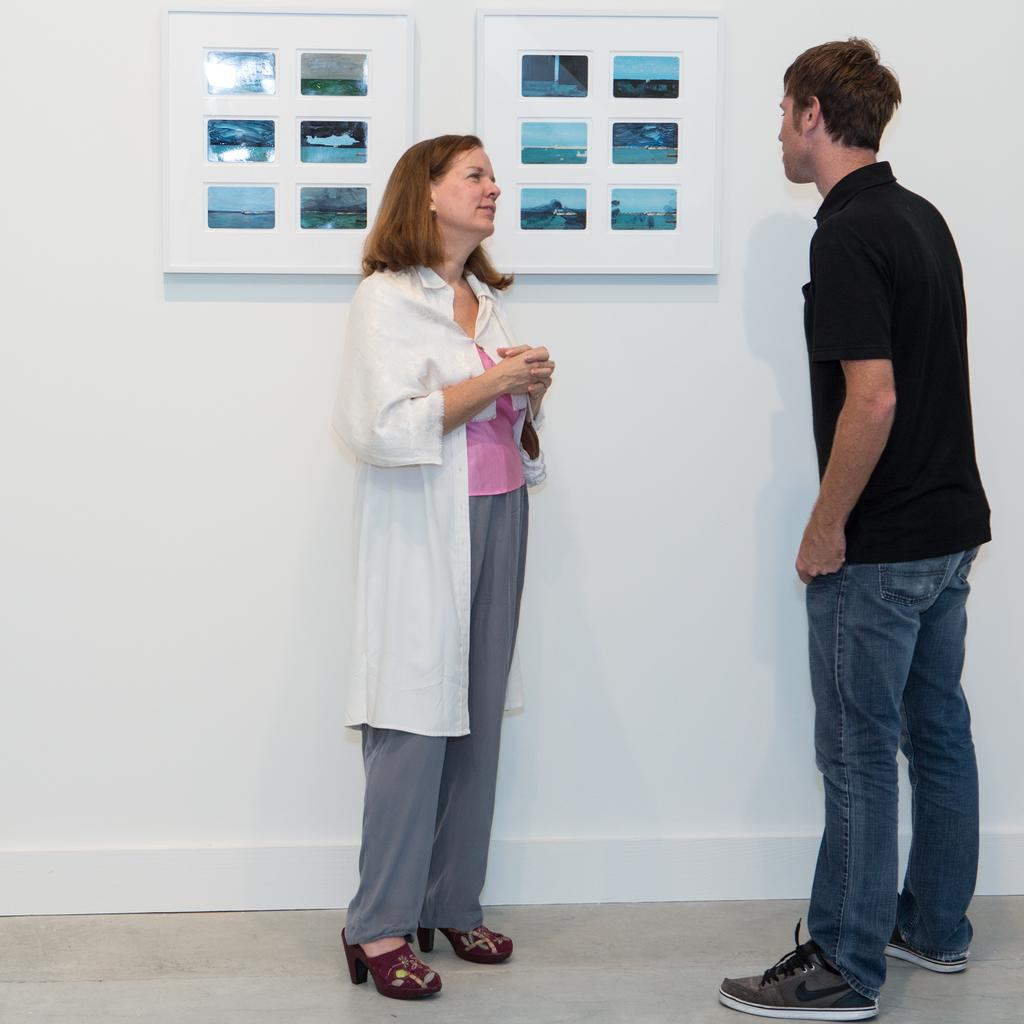How many people are in the image? There are two persons standing in the center of the image. What can be seen in the background of the image? There is a wall in the background of the image. What is visible at the bottom of the image? There is a floor visible at the bottom of the image. What type of receipt can be seen falling through the hole in the image? There is no receipt or hole present in the image. 